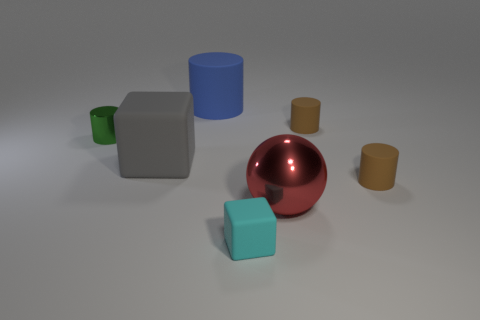What is the size of the cube that is behind the tiny cyan matte cube?
Give a very brief answer. Large. How many blue matte cylinders have the same size as the red metal sphere?
Your response must be concise. 1. Do the shiny sphere and the rubber cylinder to the left of the sphere have the same size?
Your answer should be very brief. Yes. What number of things are green things or big gray matte things?
Offer a very short reply. 2. What number of tiny cylinders are the same color as the ball?
Ensure brevity in your answer.  0. There is a green metal thing that is the same size as the cyan rubber block; what shape is it?
Provide a short and direct response. Cylinder. Is there another large red metallic thing of the same shape as the red shiny thing?
Give a very brief answer. No. How many tiny green cylinders are the same material as the red thing?
Give a very brief answer. 1. Is the big thing that is right of the blue rubber cylinder made of the same material as the big blue thing?
Keep it short and to the point. No. Is the number of green metallic cylinders that are on the right side of the tiny green metallic thing greater than the number of large balls on the left side of the gray matte cube?
Your response must be concise. No. 